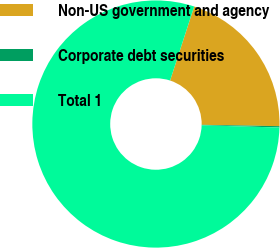Convert chart to OTSL. <chart><loc_0><loc_0><loc_500><loc_500><pie_chart><fcel>Non-US government and agency<fcel>Corporate debt securities<fcel>Total 1<nl><fcel>20.27%<fcel>0.17%<fcel>79.56%<nl></chart> 